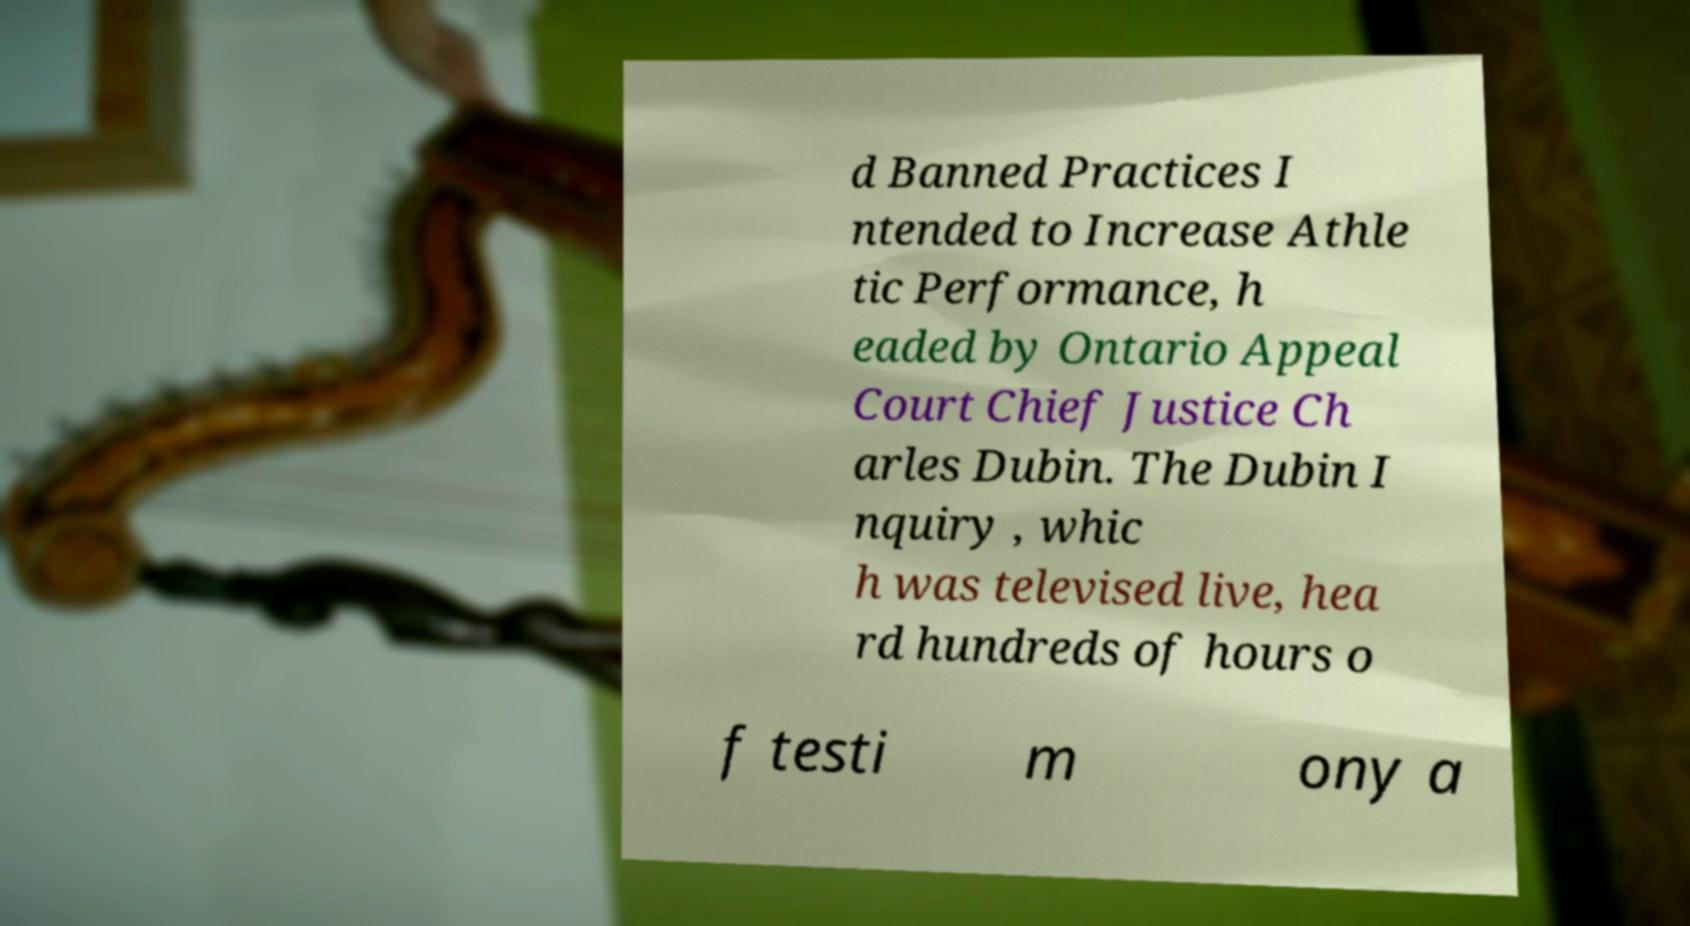There's text embedded in this image that I need extracted. Can you transcribe it verbatim? d Banned Practices I ntended to Increase Athle tic Performance, h eaded by Ontario Appeal Court Chief Justice Ch arles Dubin. The Dubin I nquiry , whic h was televised live, hea rd hundreds of hours o f testi m ony a 